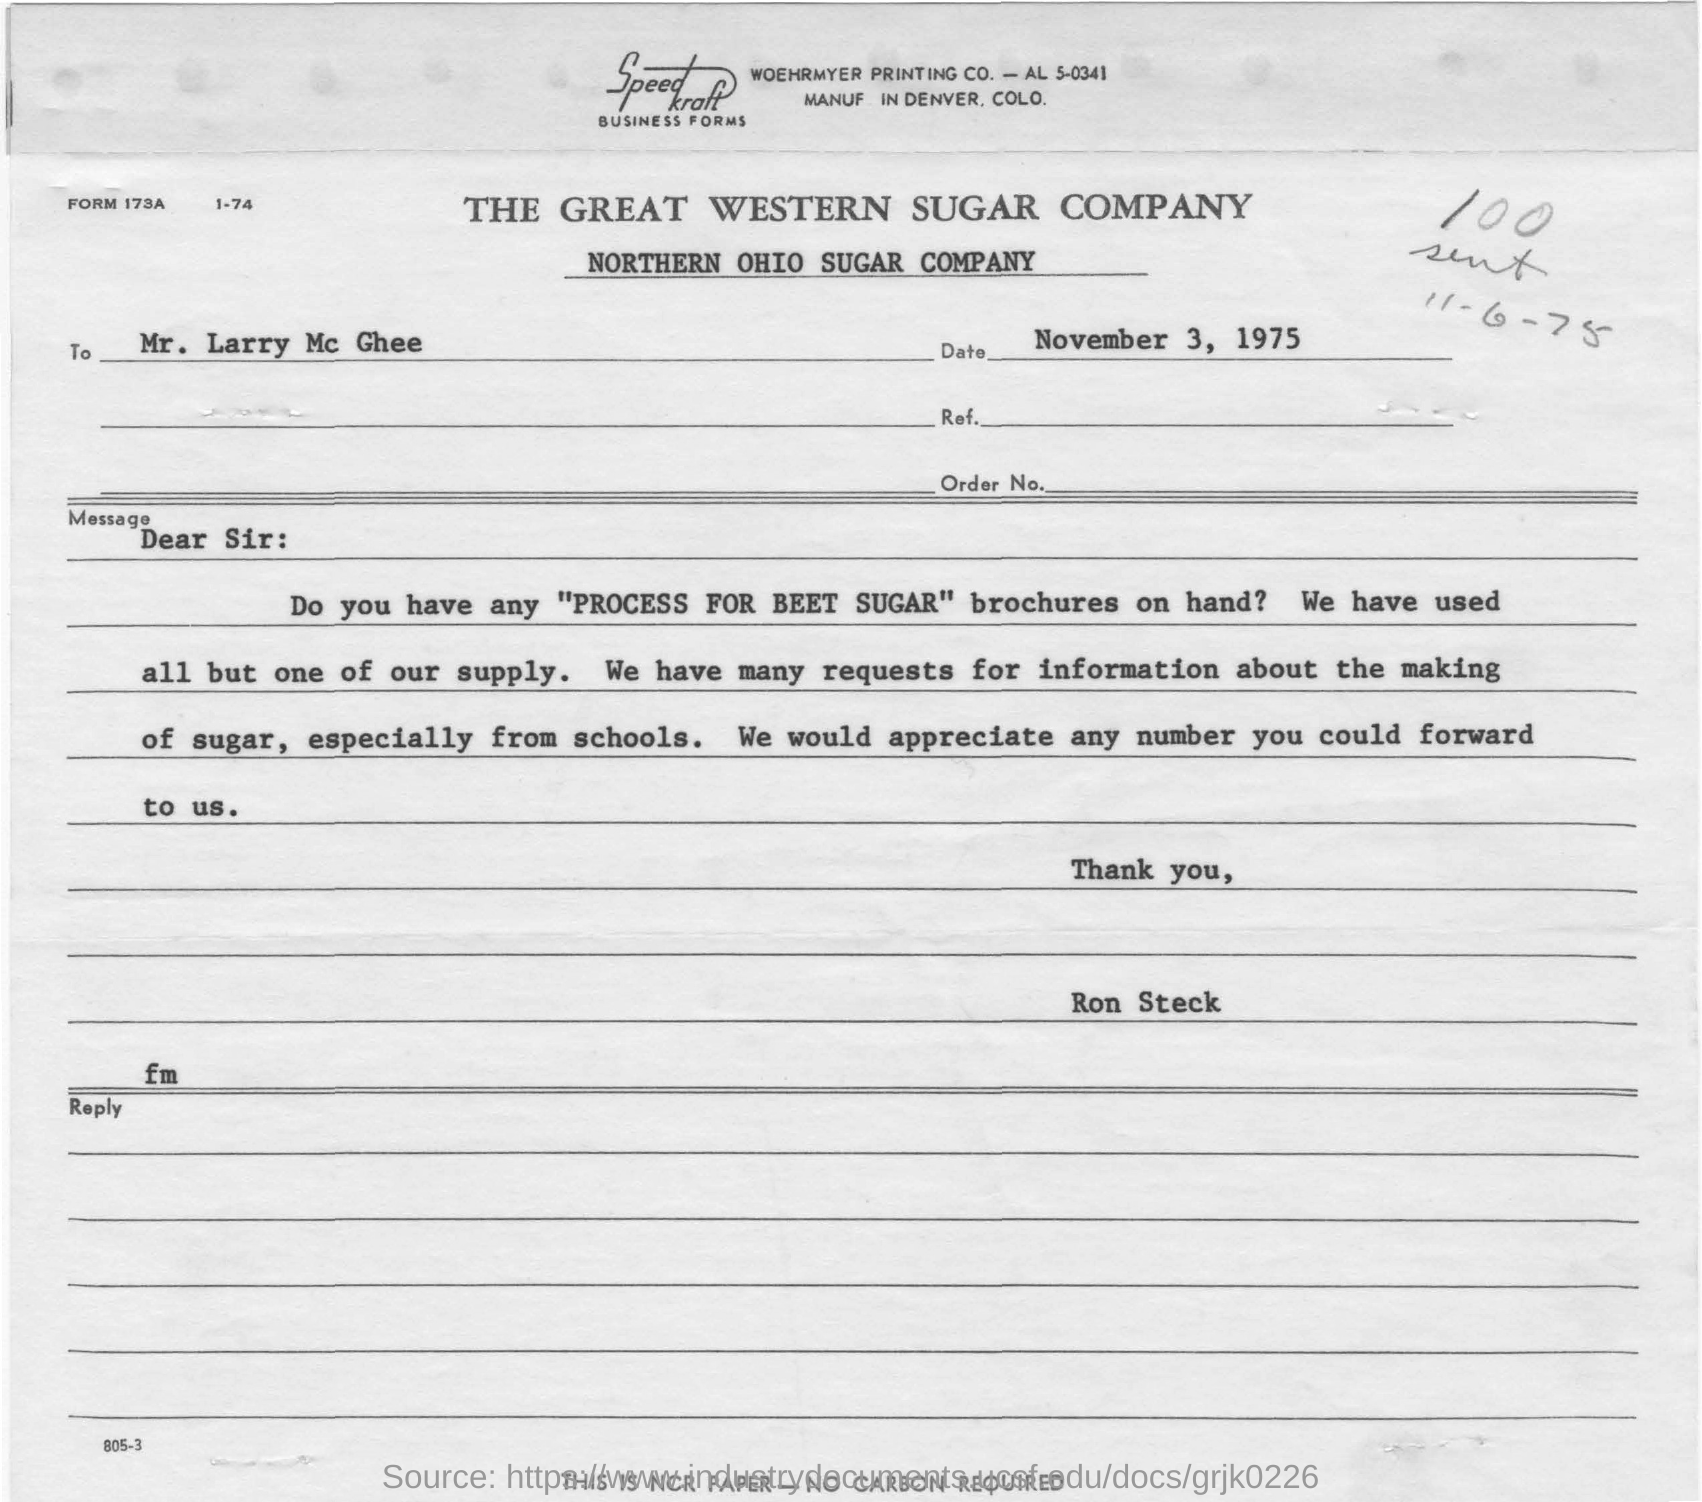What is the name of the sugar company in the title?
Your answer should be compact. The great western sugar company. What is date mentioned in the letter?
Make the answer very short. November 3, 1975. Who is writing letter to mr. larry mc ghee?
Keep it short and to the point. Ron steck. What kind of brochures are asking from larry mc ghee?
Give a very brief answer. "PROCESS FOR BEET SUGAR" brochures. What is the subtitle under the title of "the great western sugar company"?
Give a very brief answer. Northern ohio sugar company. What is the date mentioned with pencil in the letter?
Give a very brief answer. 11-6-75. Which printing company in the letter?
Make the answer very short. WOEHRMYER PRINTING CO. From where are they  having many requests for information about making of sugar?
Keep it short and to the point. Schools. 